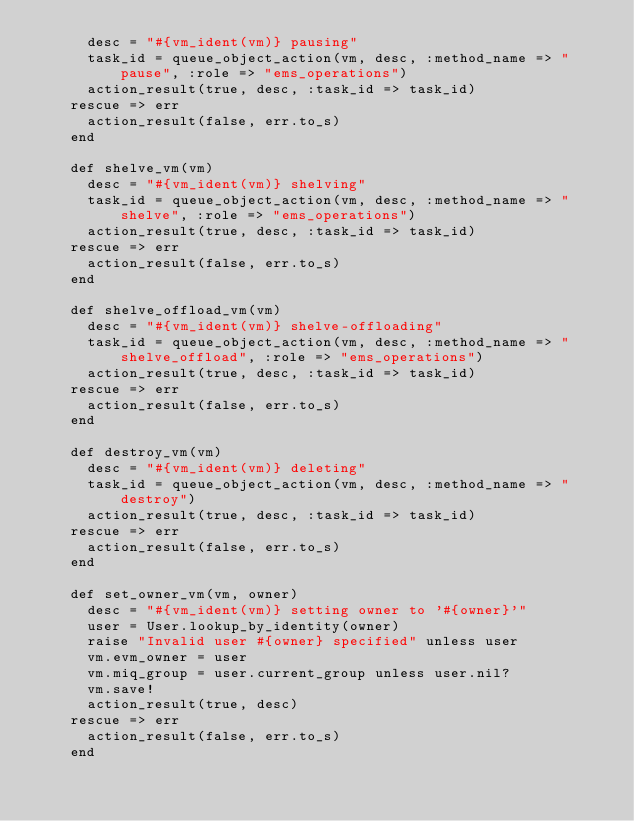<code> <loc_0><loc_0><loc_500><loc_500><_Ruby_>      desc = "#{vm_ident(vm)} pausing"
      task_id = queue_object_action(vm, desc, :method_name => "pause", :role => "ems_operations")
      action_result(true, desc, :task_id => task_id)
    rescue => err
      action_result(false, err.to_s)
    end

    def shelve_vm(vm)
      desc = "#{vm_ident(vm)} shelving"
      task_id = queue_object_action(vm, desc, :method_name => "shelve", :role => "ems_operations")
      action_result(true, desc, :task_id => task_id)
    rescue => err
      action_result(false, err.to_s)
    end

    def shelve_offload_vm(vm)
      desc = "#{vm_ident(vm)} shelve-offloading"
      task_id = queue_object_action(vm, desc, :method_name => "shelve_offload", :role => "ems_operations")
      action_result(true, desc, :task_id => task_id)
    rescue => err
      action_result(false, err.to_s)
    end

    def destroy_vm(vm)
      desc = "#{vm_ident(vm)} deleting"
      task_id = queue_object_action(vm, desc, :method_name => "destroy")
      action_result(true, desc, :task_id => task_id)
    rescue => err
      action_result(false, err.to_s)
    end

    def set_owner_vm(vm, owner)
      desc = "#{vm_ident(vm)} setting owner to '#{owner}'"
      user = User.lookup_by_identity(owner)
      raise "Invalid user #{owner} specified" unless user
      vm.evm_owner = user
      vm.miq_group = user.current_group unless user.nil?
      vm.save!
      action_result(true, desc)
    rescue => err
      action_result(false, err.to_s)
    end
</code> 